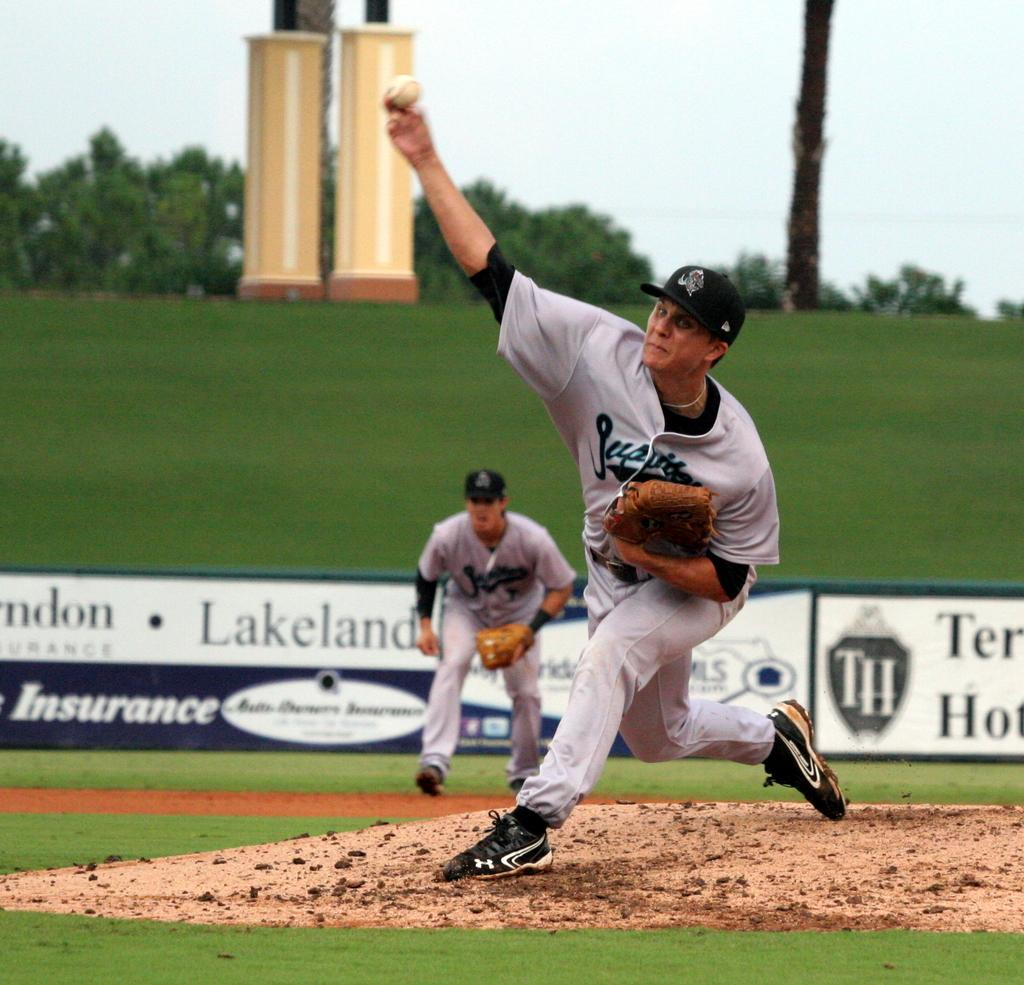<image>
Offer a succinct explanation of the picture presented. Two men playing baseball with the word Lakeland behind one of them 